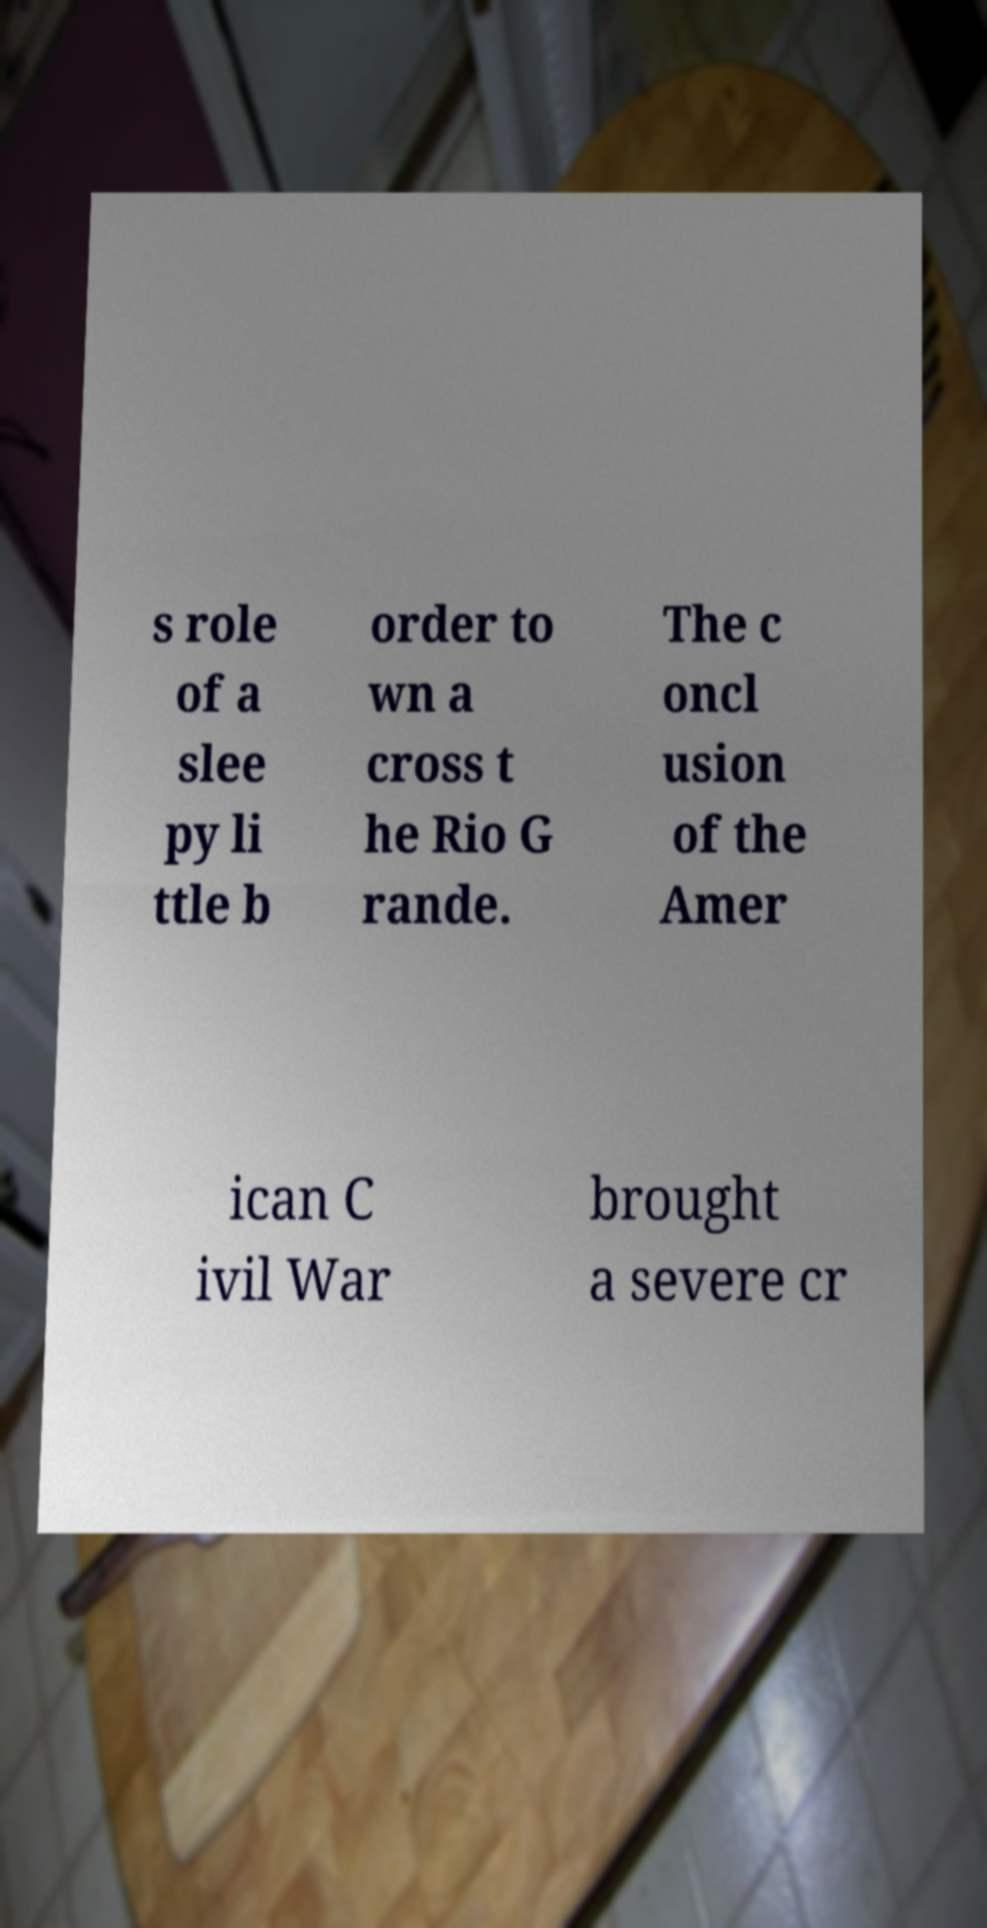Could you extract and type out the text from this image? s role of a slee py li ttle b order to wn a cross t he Rio G rande. The c oncl usion of the Amer ican C ivil War brought a severe cr 